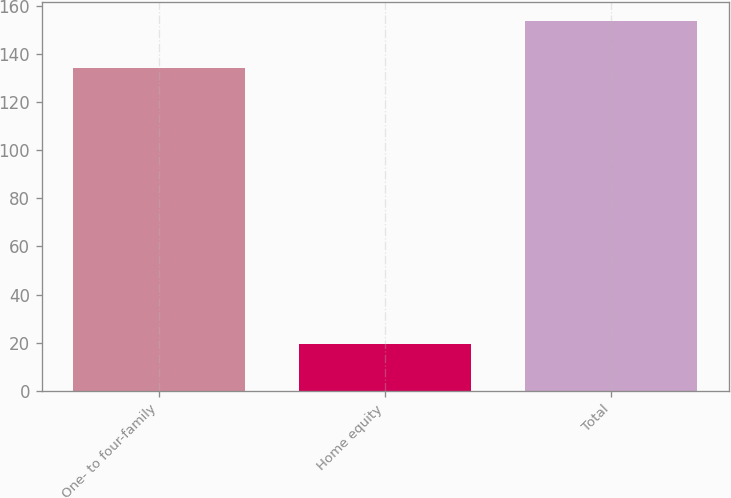<chart> <loc_0><loc_0><loc_500><loc_500><bar_chart><fcel>One- to four-family<fcel>Home equity<fcel>Total<nl><fcel>134.1<fcel>19.6<fcel>153.7<nl></chart> 